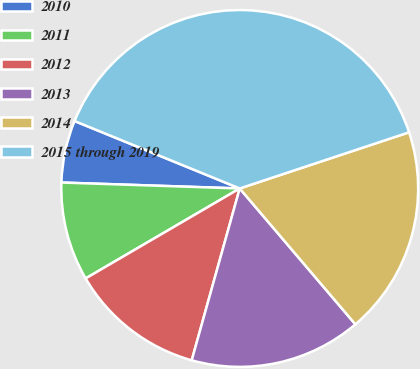Convert chart. <chart><loc_0><loc_0><loc_500><loc_500><pie_chart><fcel>2010<fcel>2011<fcel>2012<fcel>2013<fcel>2014<fcel>2015 through 2019<nl><fcel>5.64%<fcel>8.94%<fcel>12.25%<fcel>15.56%<fcel>18.87%<fcel>38.73%<nl></chart> 